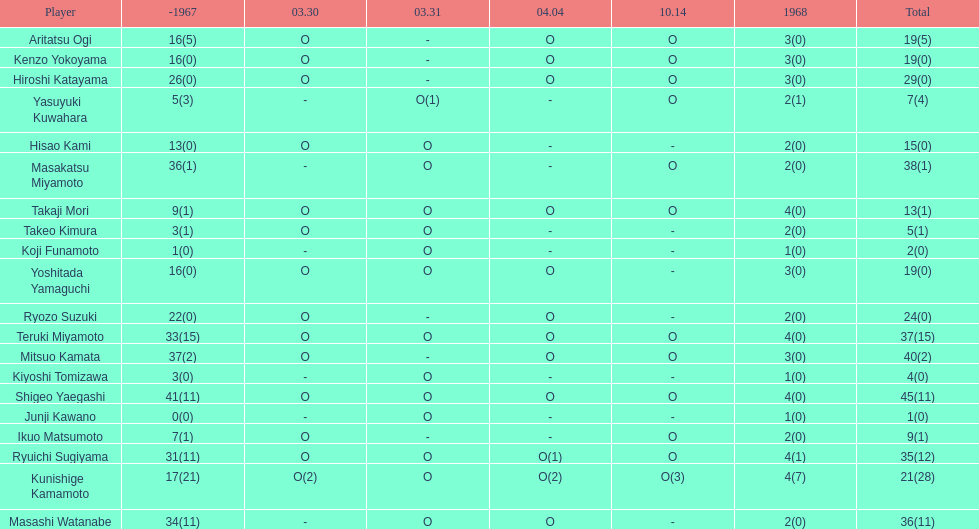How many players made an appearance that year? 20. 